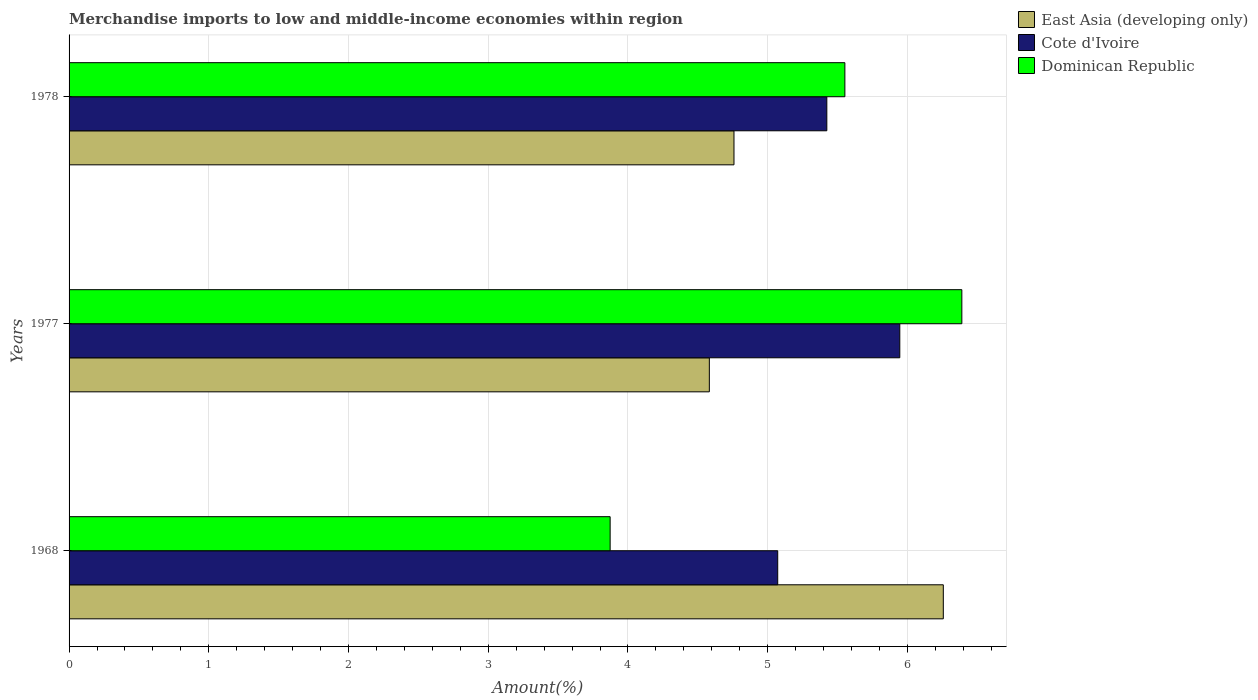Are the number of bars per tick equal to the number of legend labels?
Offer a terse response. Yes. Are the number of bars on each tick of the Y-axis equal?
Provide a succinct answer. Yes. How many bars are there on the 3rd tick from the top?
Ensure brevity in your answer.  3. What is the label of the 3rd group of bars from the top?
Offer a very short reply. 1968. In how many cases, is the number of bars for a given year not equal to the number of legend labels?
Offer a very short reply. 0. What is the percentage of amount earned from merchandise imports in Cote d'Ivoire in 1968?
Your answer should be very brief. 5.07. Across all years, what is the maximum percentage of amount earned from merchandise imports in Dominican Republic?
Give a very brief answer. 6.39. Across all years, what is the minimum percentage of amount earned from merchandise imports in Dominican Republic?
Offer a terse response. 3.87. In which year was the percentage of amount earned from merchandise imports in East Asia (developing only) maximum?
Give a very brief answer. 1968. In which year was the percentage of amount earned from merchandise imports in East Asia (developing only) minimum?
Keep it short and to the point. 1977. What is the total percentage of amount earned from merchandise imports in Dominican Republic in the graph?
Your response must be concise. 15.81. What is the difference between the percentage of amount earned from merchandise imports in Dominican Republic in 1968 and that in 1978?
Offer a terse response. -1.68. What is the difference between the percentage of amount earned from merchandise imports in East Asia (developing only) in 1977 and the percentage of amount earned from merchandise imports in Cote d'Ivoire in 1968?
Make the answer very short. -0.49. What is the average percentage of amount earned from merchandise imports in Cote d'Ivoire per year?
Keep it short and to the point. 5.48. In the year 1977, what is the difference between the percentage of amount earned from merchandise imports in Cote d'Ivoire and percentage of amount earned from merchandise imports in Dominican Republic?
Keep it short and to the point. -0.44. What is the ratio of the percentage of amount earned from merchandise imports in Cote d'Ivoire in 1968 to that in 1978?
Your answer should be very brief. 0.94. Is the difference between the percentage of amount earned from merchandise imports in Cote d'Ivoire in 1968 and 1977 greater than the difference between the percentage of amount earned from merchandise imports in Dominican Republic in 1968 and 1977?
Make the answer very short. Yes. What is the difference between the highest and the second highest percentage of amount earned from merchandise imports in East Asia (developing only)?
Give a very brief answer. 1.5. What is the difference between the highest and the lowest percentage of amount earned from merchandise imports in East Asia (developing only)?
Your answer should be very brief. 1.67. In how many years, is the percentage of amount earned from merchandise imports in Cote d'Ivoire greater than the average percentage of amount earned from merchandise imports in Cote d'Ivoire taken over all years?
Provide a short and direct response. 1. What does the 3rd bar from the top in 1978 represents?
Your answer should be compact. East Asia (developing only). What does the 1st bar from the bottom in 1968 represents?
Offer a very short reply. East Asia (developing only). How many bars are there?
Provide a succinct answer. 9. Are all the bars in the graph horizontal?
Make the answer very short. Yes. How many years are there in the graph?
Your answer should be compact. 3. What is the difference between two consecutive major ticks on the X-axis?
Ensure brevity in your answer.  1. Are the values on the major ticks of X-axis written in scientific E-notation?
Your answer should be very brief. No. Does the graph contain any zero values?
Give a very brief answer. No. How are the legend labels stacked?
Offer a terse response. Vertical. What is the title of the graph?
Give a very brief answer. Merchandise imports to low and middle-income economies within region. Does "Uganda" appear as one of the legend labels in the graph?
Ensure brevity in your answer.  No. What is the label or title of the X-axis?
Your answer should be very brief. Amount(%). What is the label or title of the Y-axis?
Offer a very short reply. Years. What is the Amount(%) of East Asia (developing only) in 1968?
Your answer should be very brief. 6.26. What is the Amount(%) in Cote d'Ivoire in 1968?
Provide a succinct answer. 5.07. What is the Amount(%) of Dominican Republic in 1968?
Provide a succinct answer. 3.87. What is the Amount(%) of East Asia (developing only) in 1977?
Keep it short and to the point. 4.58. What is the Amount(%) of Cote d'Ivoire in 1977?
Your answer should be compact. 5.95. What is the Amount(%) of Dominican Republic in 1977?
Ensure brevity in your answer.  6.39. What is the Amount(%) of East Asia (developing only) in 1978?
Offer a terse response. 4.76. What is the Amount(%) of Cote d'Ivoire in 1978?
Your response must be concise. 5.42. What is the Amount(%) in Dominican Republic in 1978?
Provide a short and direct response. 5.55. Across all years, what is the maximum Amount(%) of East Asia (developing only)?
Offer a terse response. 6.26. Across all years, what is the maximum Amount(%) in Cote d'Ivoire?
Your answer should be very brief. 5.95. Across all years, what is the maximum Amount(%) of Dominican Republic?
Your answer should be compact. 6.39. Across all years, what is the minimum Amount(%) in East Asia (developing only)?
Ensure brevity in your answer.  4.58. Across all years, what is the minimum Amount(%) of Cote d'Ivoire?
Your answer should be very brief. 5.07. Across all years, what is the minimum Amount(%) of Dominican Republic?
Offer a terse response. 3.87. What is the total Amount(%) of East Asia (developing only) in the graph?
Offer a very short reply. 15.6. What is the total Amount(%) of Cote d'Ivoire in the graph?
Your response must be concise. 16.44. What is the total Amount(%) of Dominican Republic in the graph?
Your response must be concise. 15.81. What is the difference between the Amount(%) of East Asia (developing only) in 1968 and that in 1977?
Give a very brief answer. 1.67. What is the difference between the Amount(%) of Cote d'Ivoire in 1968 and that in 1977?
Ensure brevity in your answer.  -0.87. What is the difference between the Amount(%) of Dominican Republic in 1968 and that in 1977?
Keep it short and to the point. -2.52. What is the difference between the Amount(%) of East Asia (developing only) in 1968 and that in 1978?
Provide a succinct answer. 1.5. What is the difference between the Amount(%) in Cote d'Ivoire in 1968 and that in 1978?
Your answer should be very brief. -0.35. What is the difference between the Amount(%) in Dominican Republic in 1968 and that in 1978?
Offer a terse response. -1.68. What is the difference between the Amount(%) in East Asia (developing only) in 1977 and that in 1978?
Keep it short and to the point. -0.18. What is the difference between the Amount(%) in Cote d'Ivoire in 1977 and that in 1978?
Give a very brief answer. 0.52. What is the difference between the Amount(%) of Dominican Republic in 1977 and that in 1978?
Make the answer very short. 0.84. What is the difference between the Amount(%) of East Asia (developing only) in 1968 and the Amount(%) of Cote d'Ivoire in 1977?
Your answer should be compact. 0.31. What is the difference between the Amount(%) of East Asia (developing only) in 1968 and the Amount(%) of Dominican Republic in 1977?
Provide a short and direct response. -0.13. What is the difference between the Amount(%) of Cote d'Ivoire in 1968 and the Amount(%) of Dominican Republic in 1977?
Your answer should be compact. -1.32. What is the difference between the Amount(%) in East Asia (developing only) in 1968 and the Amount(%) in Cote d'Ivoire in 1978?
Keep it short and to the point. 0.83. What is the difference between the Amount(%) in East Asia (developing only) in 1968 and the Amount(%) in Dominican Republic in 1978?
Provide a short and direct response. 0.7. What is the difference between the Amount(%) of Cote d'Ivoire in 1968 and the Amount(%) of Dominican Republic in 1978?
Offer a terse response. -0.48. What is the difference between the Amount(%) in East Asia (developing only) in 1977 and the Amount(%) in Cote d'Ivoire in 1978?
Keep it short and to the point. -0.84. What is the difference between the Amount(%) in East Asia (developing only) in 1977 and the Amount(%) in Dominican Republic in 1978?
Your response must be concise. -0.97. What is the difference between the Amount(%) of Cote d'Ivoire in 1977 and the Amount(%) of Dominican Republic in 1978?
Provide a succinct answer. 0.39. What is the average Amount(%) in East Asia (developing only) per year?
Your answer should be compact. 5.2. What is the average Amount(%) of Cote d'Ivoire per year?
Ensure brevity in your answer.  5.48. What is the average Amount(%) in Dominican Republic per year?
Keep it short and to the point. 5.27. In the year 1968, what is the difference between the Amount(%) in East Asia (developing only) and Amount(%) in Cote d'Ivoire?
Give a very brief answer. 1.19. In the year 1968, what is the difference between the Amount(%) of East Asia (developing only) and Amount(%) of Dominican Republic?
Your answer should be very brief. 2.38. In the year 1968, what is the difference between the Amount(%) of Cote d'Ivoire and Amount(%) of Dominican Republic?
Make the answer very short. 1.2. In the year 1977, what is the difference between the Amount(%) of East Asia (developing only) and Amount(%) of Cote d'Ivoire?
Your answer should be compact. -1.36. In the year 1977, what is the difference between the Amount(%) in East Asia (developing only) and Amount(%) in Dominican Republic?
Offer a terse response. -1.81. In the year 1977, what is the difference between the Amount(%) of Cote d'Ivoire and Amount(%) of Dominican Republic?
Provide a succinct answer. -0.44. In the year 1978, what is the difference between the Amount(%) of East Asia (developing only) and Amount(%) of Cote d'Ivoire?
Your answer should be compact. -0.66. In the year 1978, what is the difference between the Amount(%) in East Asia (developing only) and Amount(%) in Dominican Republic?
Your response must be concise. -0.79. In the year 1978, what is the difference between the Amount(%) in Cote d'Ivoire and Amount(%) in Dominican Republic?
Your answer should be compact. -0.13. What is the ratio of the Amount(%) of East Asia (developing only) in 1968 to that in 1977?
Your answer should be compact. 1.37. What is the ratio of the Amount(%) of Cote d'Ivoire in 1968 to that in 1977?
Offer a terse response. 0.85. What is the ratio of the Amount(%) in Dominican Republic in 1968 to that in 1977?
Provide a succinct answer. 0.61. What is the ratio of the Amount(%) in East Asia (developing only) in 1968 to that in 1978?
Your response must be concise. 1.31. What is the ratio of the Amount(%) of Cote d'Ivoire in 1968 to that in 1978?
Provide a short and direct response. 0.94. What is the ratio of the Amount(%) of Dominican Republic in 1968 to that in 1978?
Your response must be concise. 0.7. What is the ratio of the Amount(%) in East Asia (developing only) in 1977 to that in 1978?
Your answer should be very brief. 0.96. What is the ratio of the Amount(%) in Cote d'Ivoire in 1977 to that in 1978?
Your answer should be very brief. 1.1. What is the ratio of the Amount(%) in Dominican Republic in 1977 to that in 1978?
Your answer should be compact. 1.15. What is the difference between the highest and the second highest Amount(%) of East Asia (developing only)?
Offer a very short reply. 1.5. What is the difference between the highest and the second highest Amount(%) of Cote d'Ivoire?
Offer a terse response. 0.52. What is the difference between the highest and the second highest Amount(%) in Dominican Republic?
Offer a terse response. 0.84. What is the difference between the highest and the lowest Amount(%) in East Asia (developing only)?
Provide a short and direct response. 1.67. What is the difference between the highest and the lowest Amount(%) in Cote d'Ivoire?
Offer a very short reply. 0.87. What is the difference between the highest and the lowest Amount(%) in Dominican Republic?
Your answer should be compact. 2.52. 